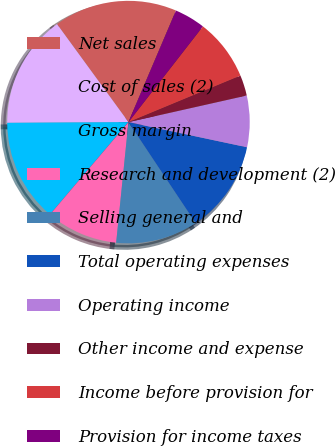Convert chart to OTSL. <chart><loc_0><loc_0><loc_500><loc_500><pie_chart><fcel>Net sales<fcel>Cost of sales (2)<fcel>Gross margin<fcel>Research and development (2)<fcel>Selling general and<fcel>Total operating expenses<fcel>Operating income<fcel>Other income and expense<fcel>Income before provision for<fcel>Provision for income taxes<nl><fcel>16.44%<fcel>15.07%<fcel>13.7%<fcel>9.59%<fcel>10.96%<fcel>12.33%<fcel>6.85%<fcel>2.74%<fcel>8.22%<fcel>4.11%<nl></chart> 